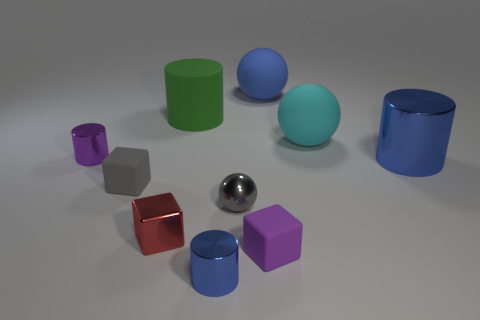What number of small shiny things have the same color as the big metal cylinder?
Offer a terse response. 1. There is a shiny cylinder that is behind the tiny sphere and left of the big blue rubber object; what size is it?
Ensure brevity in your answer.  Small. Is the number of tiny purple things that are behind the large green matte cylinder less than the number of cyan objects?
Your answer should be very brief. Yes. Is the tiny gray sphere made of the same material as the red block?
Your answer should be compact. Yes. How many things are matte cylinders or large blue cubes?
Provide a succinct answer. 1. How many large red things have the same material as the purple cylinder?
Provide a succinct answer. 0. What is the size of the gray rubber object that is the same shape as the red object?
Offer a very short reply. Small. There is a green matte thing; are there any big green cylinders on the left side of it?
Ensure brevity in your answer.  No. What is the material of the small blue cylinder?
Your response must be concise. Metal. There is a tiny cylinder that is in front of the red metallic cube; is its color the same as the small ball?
Provide a short and direct response. No. 